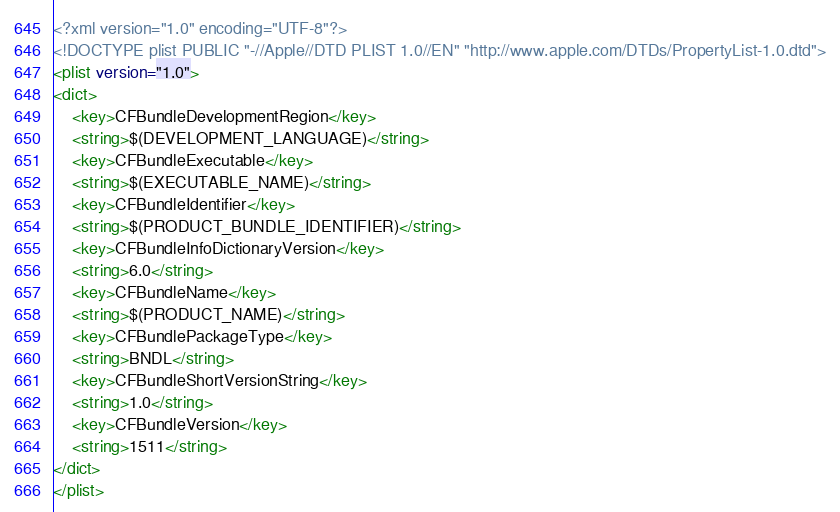<code> <loc_0><loc_0><loc_500><loc_500><_XML_><?xml version="1.0" encoding="UTF-8"?>
<!DOCTYPE plist PUBLIC "-//Apple//DTD PLIST 1.0//EN" "http://www.apple.com/DTDs/PropertyList-1.0.dtd">
<plist version="1.0">
<dict>
	<key>CFBundleDevelopmentRegion</key>
	<string>$(DEVELOPMENT_LANGUAGE)</string>
	<key>CFBundleExecutable</key>
	<string>$(EXECUTABLE_NAME)</string>
	<key>CFBundleIdentifier</key>
	<string>$(PRODUCT_BUNDLE_IDENTIFIER)</string>
	<key>CFBundleInfoDictionaryVersion</key>
	<string>6.0</string>
	<key>CFBundleName</key>
	<string>$(PRODUCT_NAME)</string>
	<key>CFBundlePackageType</key>
	<string>BNDL</string>
	<key>CFBundleShortVersionString</key>
	<string>1.0</string>
	<key>CFBundleVersion</key>
	<string>1511</string>
</dict>
</plist>
</code> 